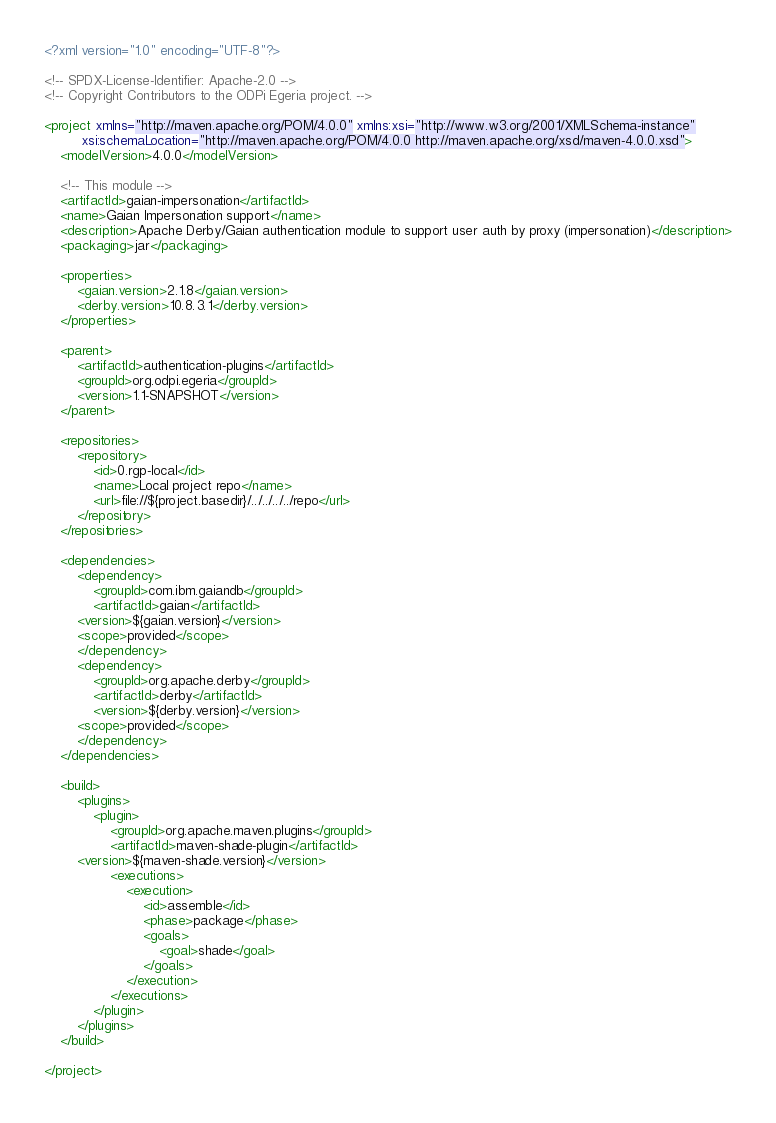<code> <loc_0><loc_0><loc_500><loc_500><_XML_><?xml version="1.0" encoding="UTF-8"?>

<!-- SPDX-License-Identifier: Apache-2.0 -->
<!-- Copyright Contributors to the ODPi Egeria project. -->

<project xmlns="http://maven.apache.org/POM/4.0.0" xmlns:xsi="http://www.w3.org/2001/XMLSchema-instance"
         xsi:schemaLocation="http://maven.apache.org/POM/4.0.0 http://maven.apache.org/xsd/maven-4.0.0.xsd">
    <modelVersion>4.0.0</modelVersion>

    <!-- This module -->
    <artifactId>gaian-impersonation</artifactId>
    <name>Gaian Impersonation support</name>
    <description>Apache Derby/Gaian authentication module to support user auth by proxy (impersonation)</description>
    <packaging>jar</packaging>

    <properties>
        <gaian.version>2.1.8</gaian.version>
        <derby.version>10.8.3.1</derby.version>
    </properties>

    <parent>
        <artifactId>authentication-plugins</artifactId>
        <groupId>org.odpi.egeria</groupId>
        <version>1.1-SNAPSHOT</version>
    </parent>

    <repositories>
        <repository>
            <id>0.rgp-local</id>
            <name>Local project repo</name>
            <url>file://${project.basedir}/../../../../repo</url>
        </repository>
    </repositories>

    <dependencies>
        <dependency>
            <groupId>com.ibm.gaiandb</groupId>
            <artifactId>gaian</artifactId>
	    <version>${gaian.version}</version>
	    <scope>provided</scope>
        </dependency>
        <dependency>
            <groupId>org.apache.derby</groupId>
            <artifactId>derby</artifactId>
            <version>${derby.version}</version>
	    <scope>provided</scope>
        </dependency>
    </dependencies>

    <build>
        <plugins>
            <plugin>
                <groupId>org.apache.maven.plugins</groupId>
                <artifactId>maven-shade-plugin</artifactId>
		<version>${maven-shade.version}</version>
                <executions>
                    <execution>
                        <id>assemble</id>
                        <phase>package</phase>
                        <goals>
                            <goal>shade</goal>
                        </goals>
                    </execution>
                </executions>
            </plugin>
        </plugins>
    </build>

</project>
</code> 